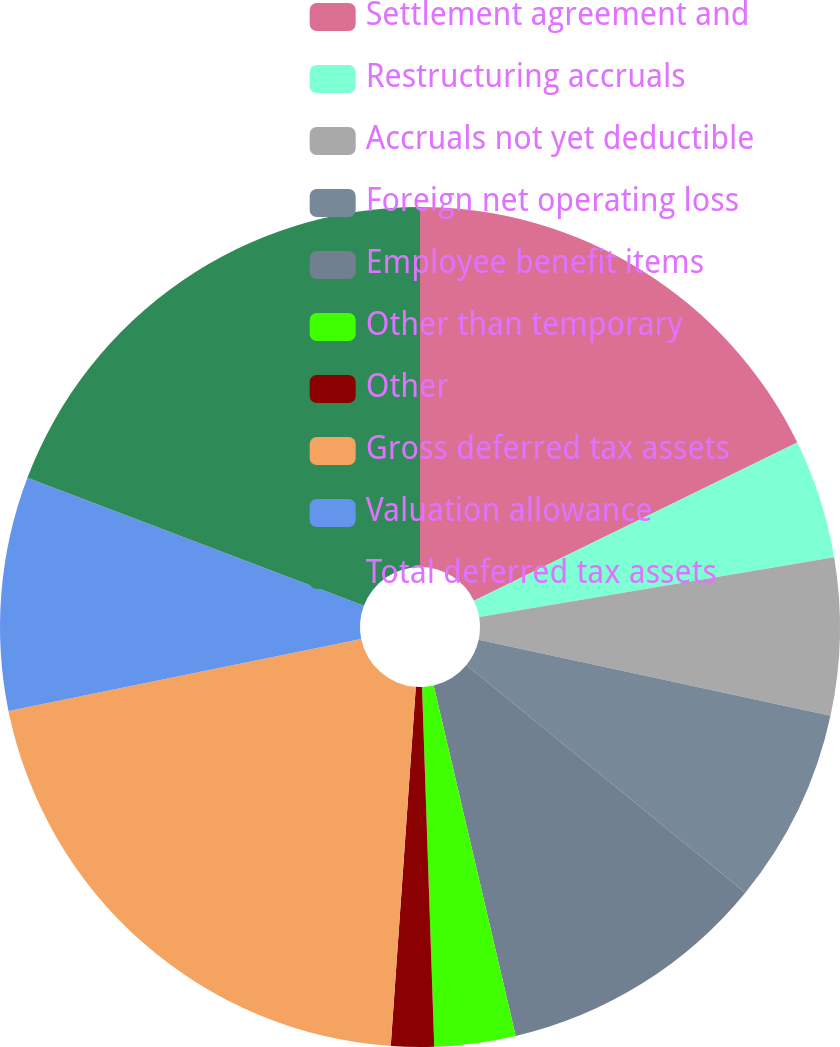<chart> <loc_0><loc_0><loc_500><loc_500><pie_chart><fcel>Settlement agreement and<fcel>Restructuring accruals<fcel>Accruals not yet deductible<fcel>Foreign net operating loss<fcel>Employee benefit items<fcel>Other than temporary<fcel>Other<fcel>Gross deferred tax assets<fcel>Valuation allowance<fcel>Total deferred tax assets<nl><fcel>17.76%<fcel>4.58%<fcel>6.05%<fcel>7.51%<fcel>10.44%<fcel>3.12%<fcel>1.65%<fcel>20.69%<fcel>8.98%<fcel>19.22%<nl></chart> 